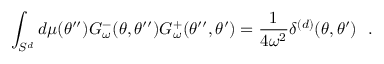<formula> <loc_0><loc_0><loc_500><loc_500>\int _ { S ^ { d } } d \mu ( \theta ^ { \prime \prime } ) G _ { \omega } ^ { - } ( \theta , \theta ^ { \prime \prime } ) G _ { \omega } ^ { + } ( \theta ^ { \prime \prime } , \theta ^ { \prime } ) = { \frac { 1 } { 4 \omega ^ { 2 } } } \delta ^ { ( d ) } ( \theta , \theta ^ { \prime } ) .</formula> 